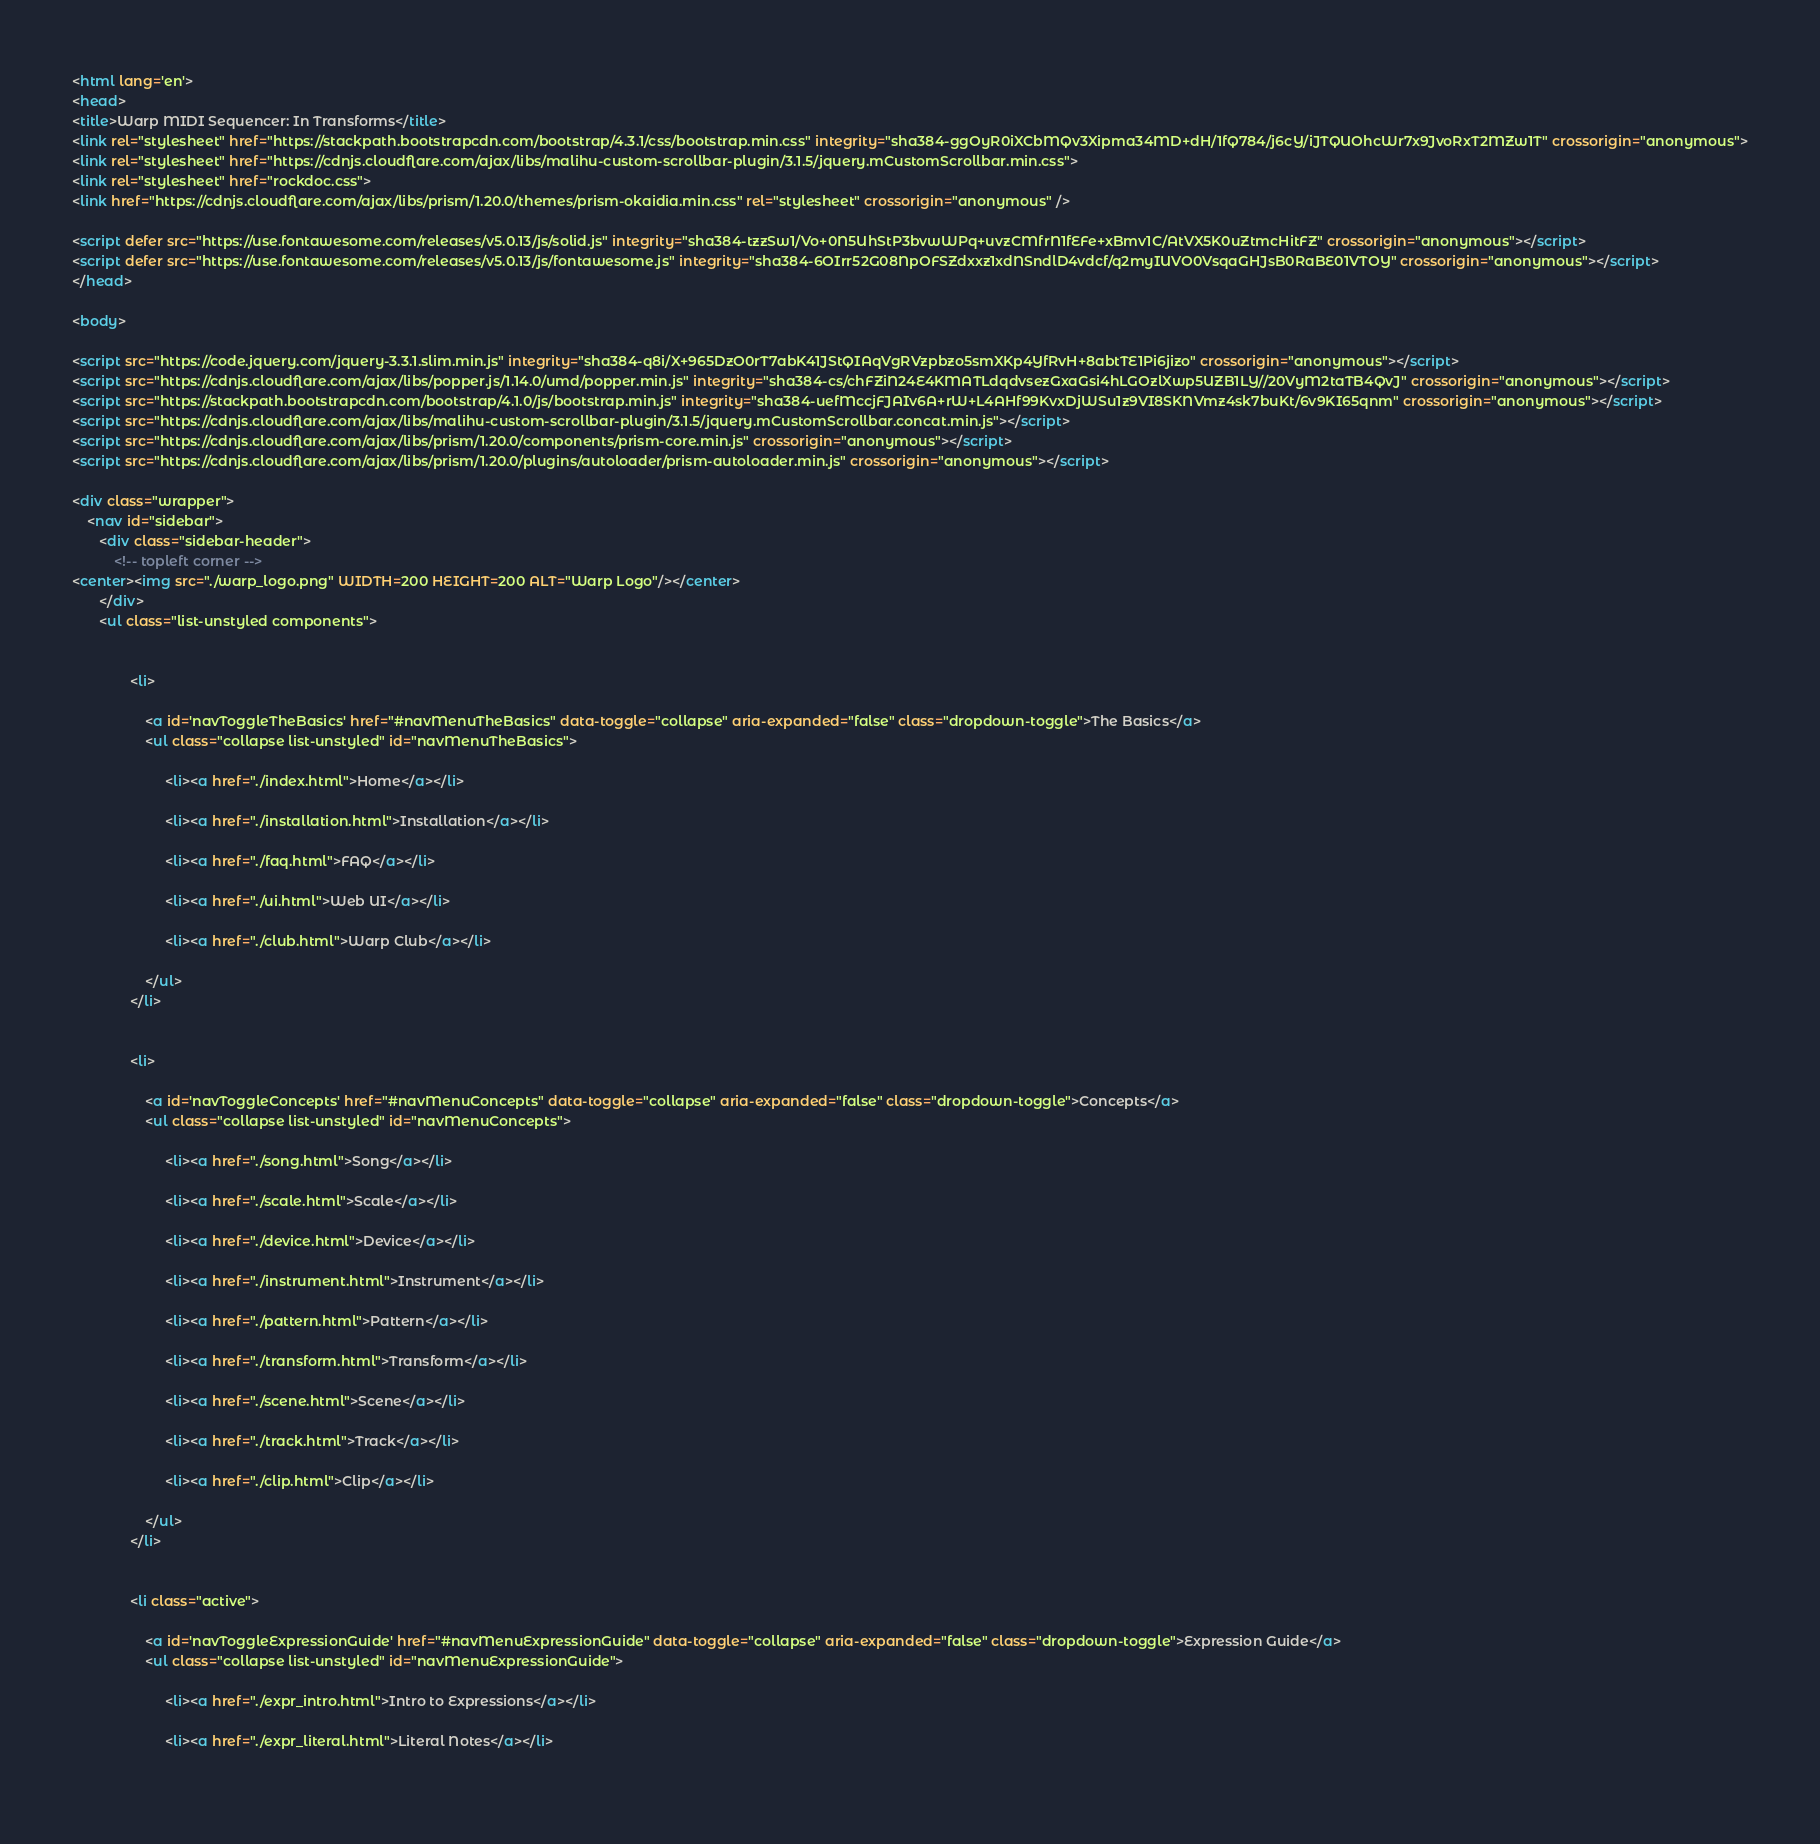Convert code to text. <code><loc_0><loc_0><loc_500><loc_500><_HTML_><html lang='en'>
<head>
<title>Warp MIDI Sequencer: In Transforms</title>
<link rel="stylesheet" href="https://stackpath.bootstrapcdn.com/bootstrap/4.3.1/css/bootstrap.min.css" integrity="sha384-ggOyR0iXCbMQv3Xipma34MD+dH/1fQ784/j6cY/iJTQUOhcWr7x9JvoRxT2MZw1T" crossorigin="anonymous">
<link rel="stylesheet" href="https://cdnjs.cloudflare.com/ajax/libs/malihu-custom-scrollbar-plugin/3.1.5/jquery.mCustomScrollbar.min.css">
<link rel="stylesheet" href="rockdoc.css">
<link href="https://cdnjs.cloudflare.com/ajax/libs/prism/1.20.0/themes/prism-okaidia.min.css" rel="stylesheet" crossorigin="anonymous" />

<script defer src="https://use.fontawesome.com/releases/v5.0.13/js/solid.js" integrity="sha384-tzzSw1/Vo+0N5UhStP3bvwWPq+uvzCMfrN1fEFe+xBmv1C/AtVX5K0uZtmcHitFZ" crossorigin="anonymous"></script>
<script defer src="https://use.fontawesome.com/releases/v5.0.13/js/fontawesome.js" integrity="sha384-6OIrr52G08NpOFSZdxxz1xdNSndlD4vdcf/q2myIUVO0VsqaGHJsB0RaBE01VTOY" crossorigin="anonymous"></script>
</head>

<body>

<script src="https://code.jquery.com/jquery-3.3.1.slim.min.js" integrity="sha384-q8i/X+965DzO0rT7abK41JStQIAqVgRVzpbzo5smXKp4YfRvH+8abtTE1Pi6jizo" crossorigin="anonymous"></script>
<script src="https://cdnjs.cloudflare.com/ajax/libs/popper.js/1.14.0/umd/popper.min.js" integrity="sha384-cs/chFZiN24E4KMATLdqdvsezGxaGsi4hLGOzlXwp5UZB1LY//20VyM2taTB4QvJ" crossorigin="anonymous"></script>
<script src="https://stackpath.bootstrapcdn.com/bootstrap/4.1.0/js/bootstrap.min.js" integrity="sha384-uefMccjFJAIv6A+rW+L4AHf99KvxDjWSu1z9VI8SKNVmz4sk7buKt/6v9KI65qnm" crossorigin="anonymous"></script>
<script src="https://cdnjs.cloudflare.com/ajax/libs/malihu-custom-scrollbar-plugin/3.1.5/jquery.mCustomScrollbar.concat.min.js"></script>
<script src="https://cdnjs.cloudflare.com/ajax/libs/prism/1.20.0/components/prism-core.min.js" crossorigin="anonymous"></script>
<script src="https://cdnjs.cloudflare.com/ajax/libs/prism/1.20.0/plugins/autoloader/prism-autoloader.min.js" crossorigin="anonymous"></script>

<div class="wrapper">
    <nav id="sidebar">
       <div class="sidebar-header">
           <!-- topleft corner -->
<center><img src="./warp_logo.png" WIDTH=200 HEIGHT=200 ALT="Warp Logo"/></center>
       </div>
       <ul class="list-unstyled components">
           
               
               <li>
               
                   <a id='navToggleTheBasics' href="#navMenuTheBasics" data-toggle="collapse" aria-expanded="false" class="dropdown-toggle">The Basics</a>
                   <ul class="collapse list-unstyled" id="navMenuTheBasics">
                   
                        <li><a href="./index.html">Home</a></li>
                   
                        <li><a href="./installation.html">Installation</a></li>
                   
                        <li><a href="./faq.html">FAQ</a></li>
                   
                        <li><a href="./ui.html">Web UI</a></li>
                   
                        <li><a href="./club.html">Warp Club</a></li>
                   
                   </ul>
               </li>
           
               
               <li>
               
                   <a id='navToggleConcepts' href="#navMenuConcepts" data-toggle="collapse" aria-expanded="false" class="dropdown-toggle">Concepts</a>
                   <ul class="collapse list-unstyled" id="navMenuConcepts">
                   
                        <li><a href="./song.html">Song</a></li>
                   
                        <li><a href="./scale.html">Scale</a></li>
                   
                        <li><a href="./device.html">Device</a></li>
                   
                        <li><a href="./instrument.html">Instrument</a></li>
                   
                        <li><a href="./pattern.html">Pattern</a></li>
                   
                        <li><a href="./transform.html">Transform</a></li>
                   
                        <li><a href="./scene.html">Scene</a></li>
                   
                        <li><a href="./track.html">Track</a></li>
                   
                        <li><a href="./clip.html">Clip</a></li>
                   
                   </ul>
               </li>
           
               
               <li class="active">
               
                   <a id='navToggleExpressionGuide' href="#navMenuExpressionGuide" data-toggle="collapse" aria-expanded="false" class="dropdown-toggle">Expression Guide</a>
                   <ul class="collapse list-unstyled" id="navMenuExpressionGuide">
                   
                        <li><a href="./expr_intro.html">Intro to Expressions</a></li>
                   
                        <li><a href="./expr_literal.html">Literal Notes</a></li>
                   </code> 